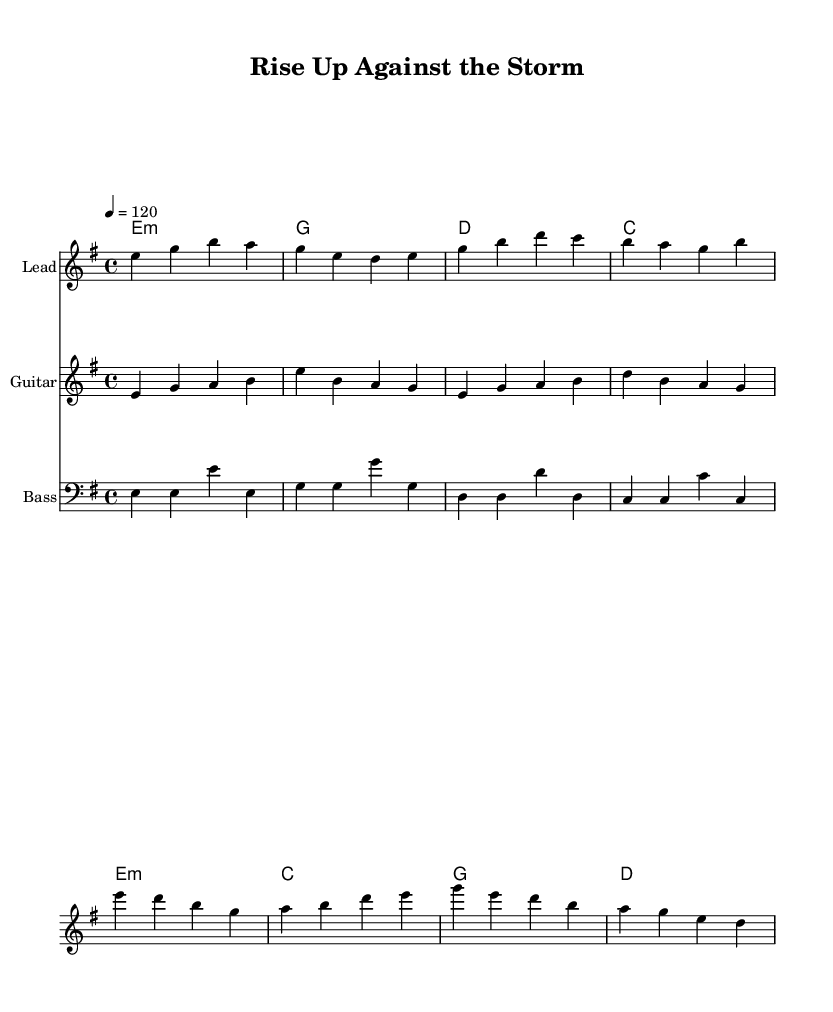What is the key signature of this music? The key signature is indicated by the presence of one flat (B♭) in the melody and harmonic structure. In this case, the piece is in E minor, which has one sharp, F♯, defining its tonal framework.
Answer: E minor What is the time signature of the piece? The time signature is indicated at the beginning of the score. Here, it is 4/4, meaning there are four beats in each measure, and a quarter note gets one beat.
Answer: 4/4 What is the tempo marking given in the sheet music? The tempo marking appears just below the time signature at the beginning, showing the intended speed of the song. It is set at 120 beats per minute, which translates to a moderate pace.
Answer: 120 What are the main chords used in the verse section? By examining the harmonies notated, the main chords for the verse section are identified as E minor (e1:m), G major, D major, and C major. These chords create the harmonic foundation of the verse.
Answer: E minor, G, D, C Which instrument is the lead melody played on? The instrument designated for the lead melody is clearly labeled in the staff; it indicates this part is played on the Lead instrument, which typically is a guitar, consistent with electric blues.
Answer: Lead How is the overall structure of the song defined? The song structure is defined by contrasting sections, which include verses and a chorus. The verses introduce the story, while the chorus emphasizes the main message of the anthem, creating a call to action.
Answer: Verse and Chorus 